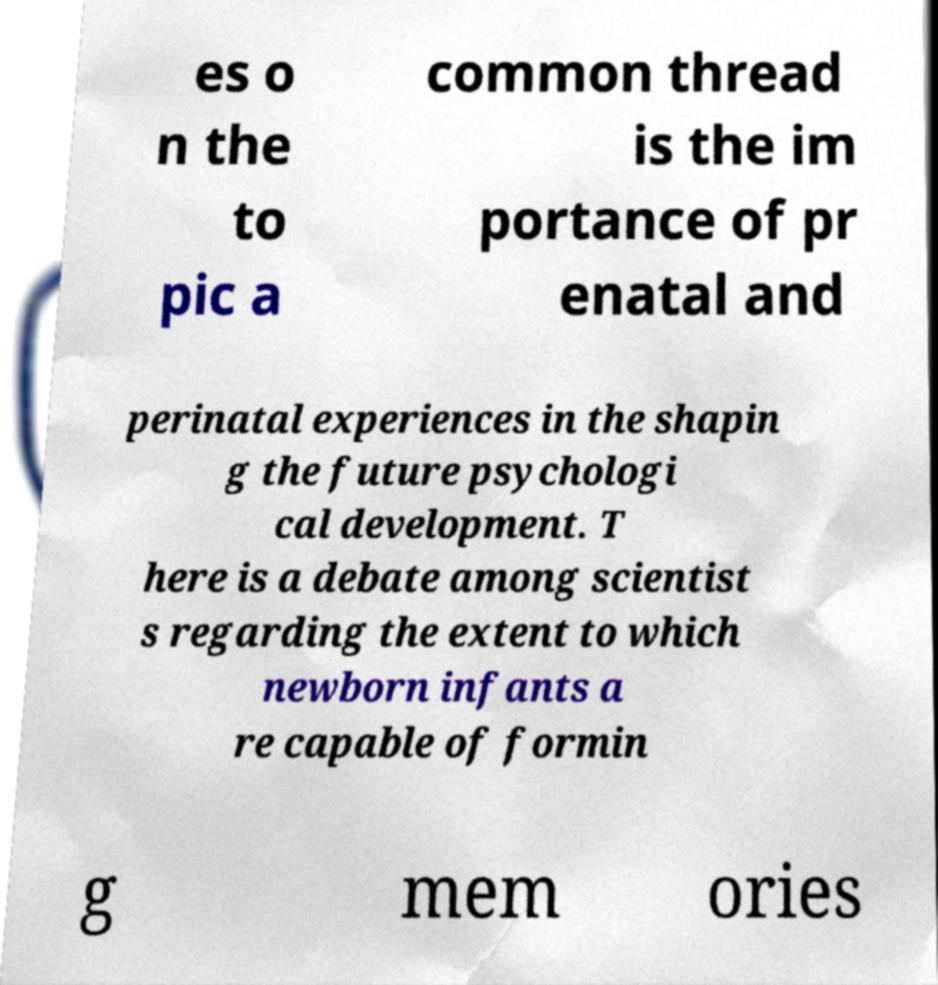For documentation purposes, I need the text within this image transcribed. Could you provide that? es o n the to pic a common thread is the im portance of pr enatal and perinatal experiences in the shapin g the future psychologi cal development. T here is a debate among scientist s regarding the extent to which newborn infants a re capable of formin g mem ories 